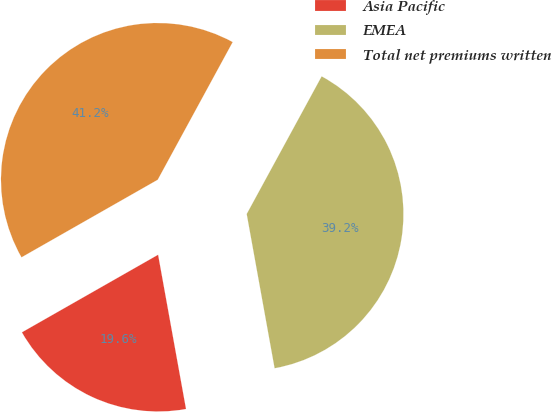Convert chart to OTSL. <chart><loc_0><loc_0><loc_500><loc_500><pie_chart><fcel>Asia Pacific<fcel>EMEA<fcel>Total net premiums written<nl><fcel>19.61%<fcel>39.22%<fcel>41.18%<nl></chart> 